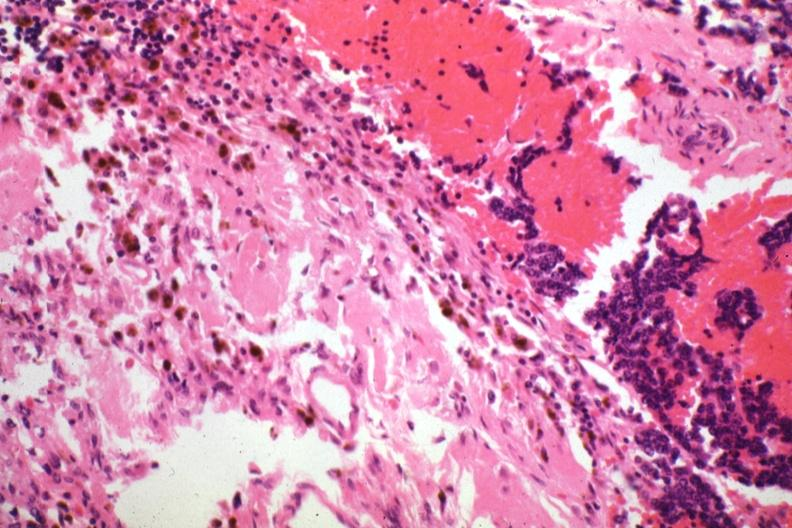does lymphangiomatosis generalized show tissue about tumor with tumor cells?
Answer the question using a single word or phrase. No 